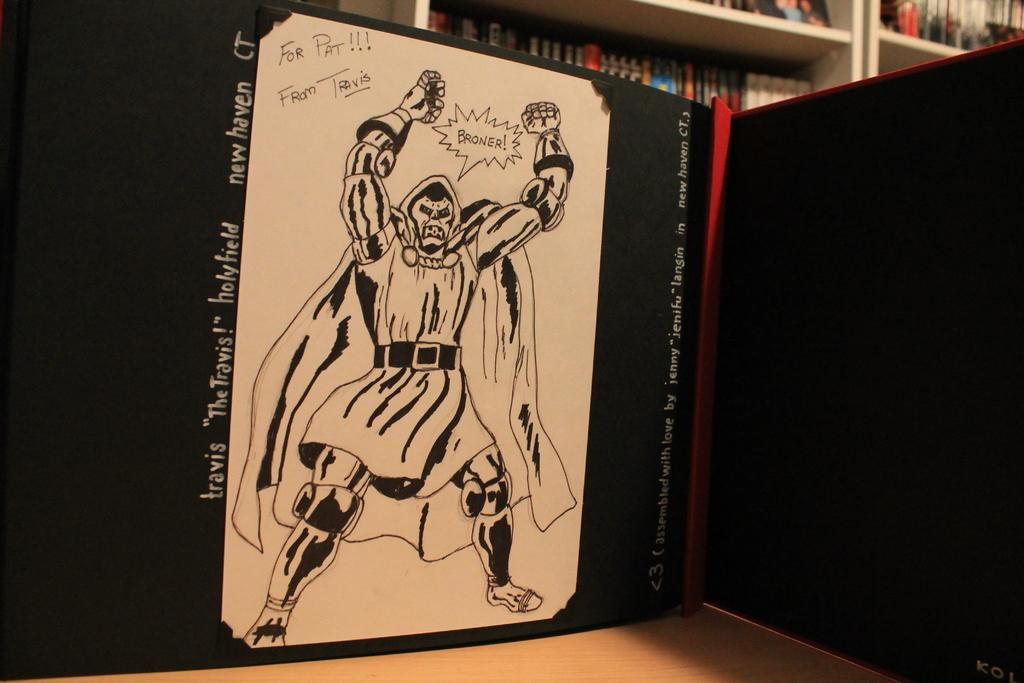<image>
Write a terse but informative summary of the picture. A drawn comic of a character that reads "The Travis". 